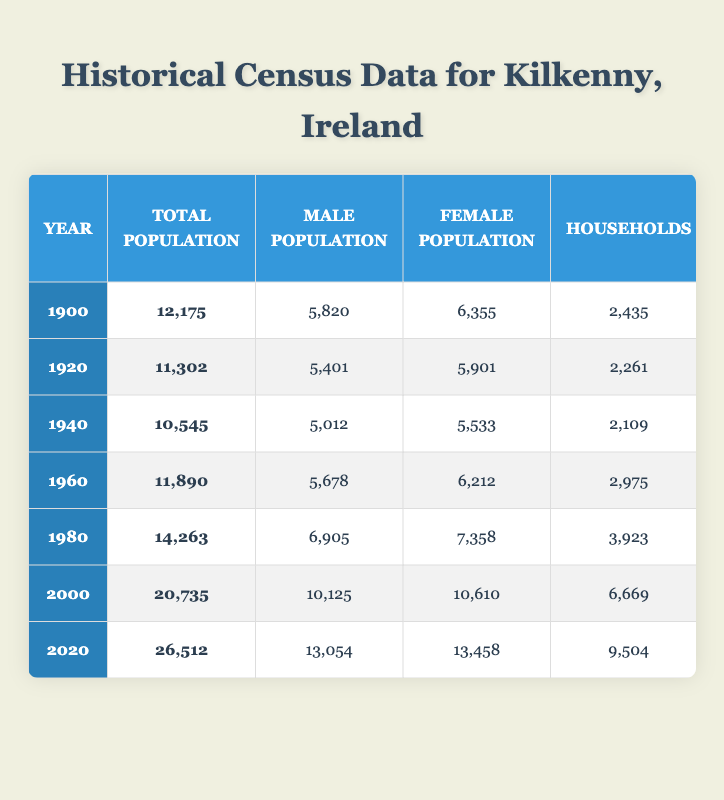What was the total population of Kilkenny in 1980? The table shows the total population for Kilkenny in 1980 as 14,263, which can be directly retrieved from the corresponding row.
Answer: 14,263 What was the primary occupation in Kilkenny in 1940? By looking at the row for the year 1940, the primary occupation listed is "Services."
Answer: Services How many male inhabitants were there in Kilkenny in 2000? The male population for the year 2000 is clearly stated in the table and is 10,125.
Answer: 10,125 Did the male population ever exceed the female population in any of the given years? We can compare the male and female populations year by year. In 1900, 5,820 males were present compared to 6,355 females, and similar comparisons show male populations were less in all years provided. Thus, the answer is no.
Answer: No What is the average household size across all recorded years? To find the average household size, we sum the values of the average household sizes across all years (5.0 + 5.0 + 5.0 + 4.0 + 3.6 + 3.1 + 2.8 = 28.5) and then divide by the number of data points, which is 7. This results in an average household size of 28.5 / 7 = 4.07.
Answer: 4.07 What was the total population decrease from 1900 to 1940? The total population in 1900 was 12,175 and in 1940 it was 10,545. The decrease is calculated by subtracting 10,545 from 12,175, resulting in a total decrease of 1,630.
Answer: 1,630 Which decade saw the highest increase in total population? To determine the decade with the highest increase, calculate the difference in population between consecutive decades: 1900 to 1920: -873, 1920 to 1940: -757, 1940 to 1960: 1,345, 1960 to 1980: 3,373, 1980 to 2000: 5,472, and 2000 to 2020: 5,777. The highest increase was from 2000 to 2020 (5,777).
Answer: 2000 to 2020 Is there a trend in primary occupations over the decades? By examining the primary occupations across the decades, we see a shift from "Agriculture" in the early 1900s to predominantly "Services" in the later years, highlighting a trend towards service-oriented occupations over time.
Answer: Yes 